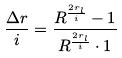Convert formula to latex. <formula><loc_0><loc_0><loc_500><loc_500>\frac { \Delta r } { i } = \frac { R ^ { \frac { 2 r _ { l } } { i } } - 1 } { R ^ { \frac { 2 r _ { l } } { i } } \cdot 1 }</formula> 